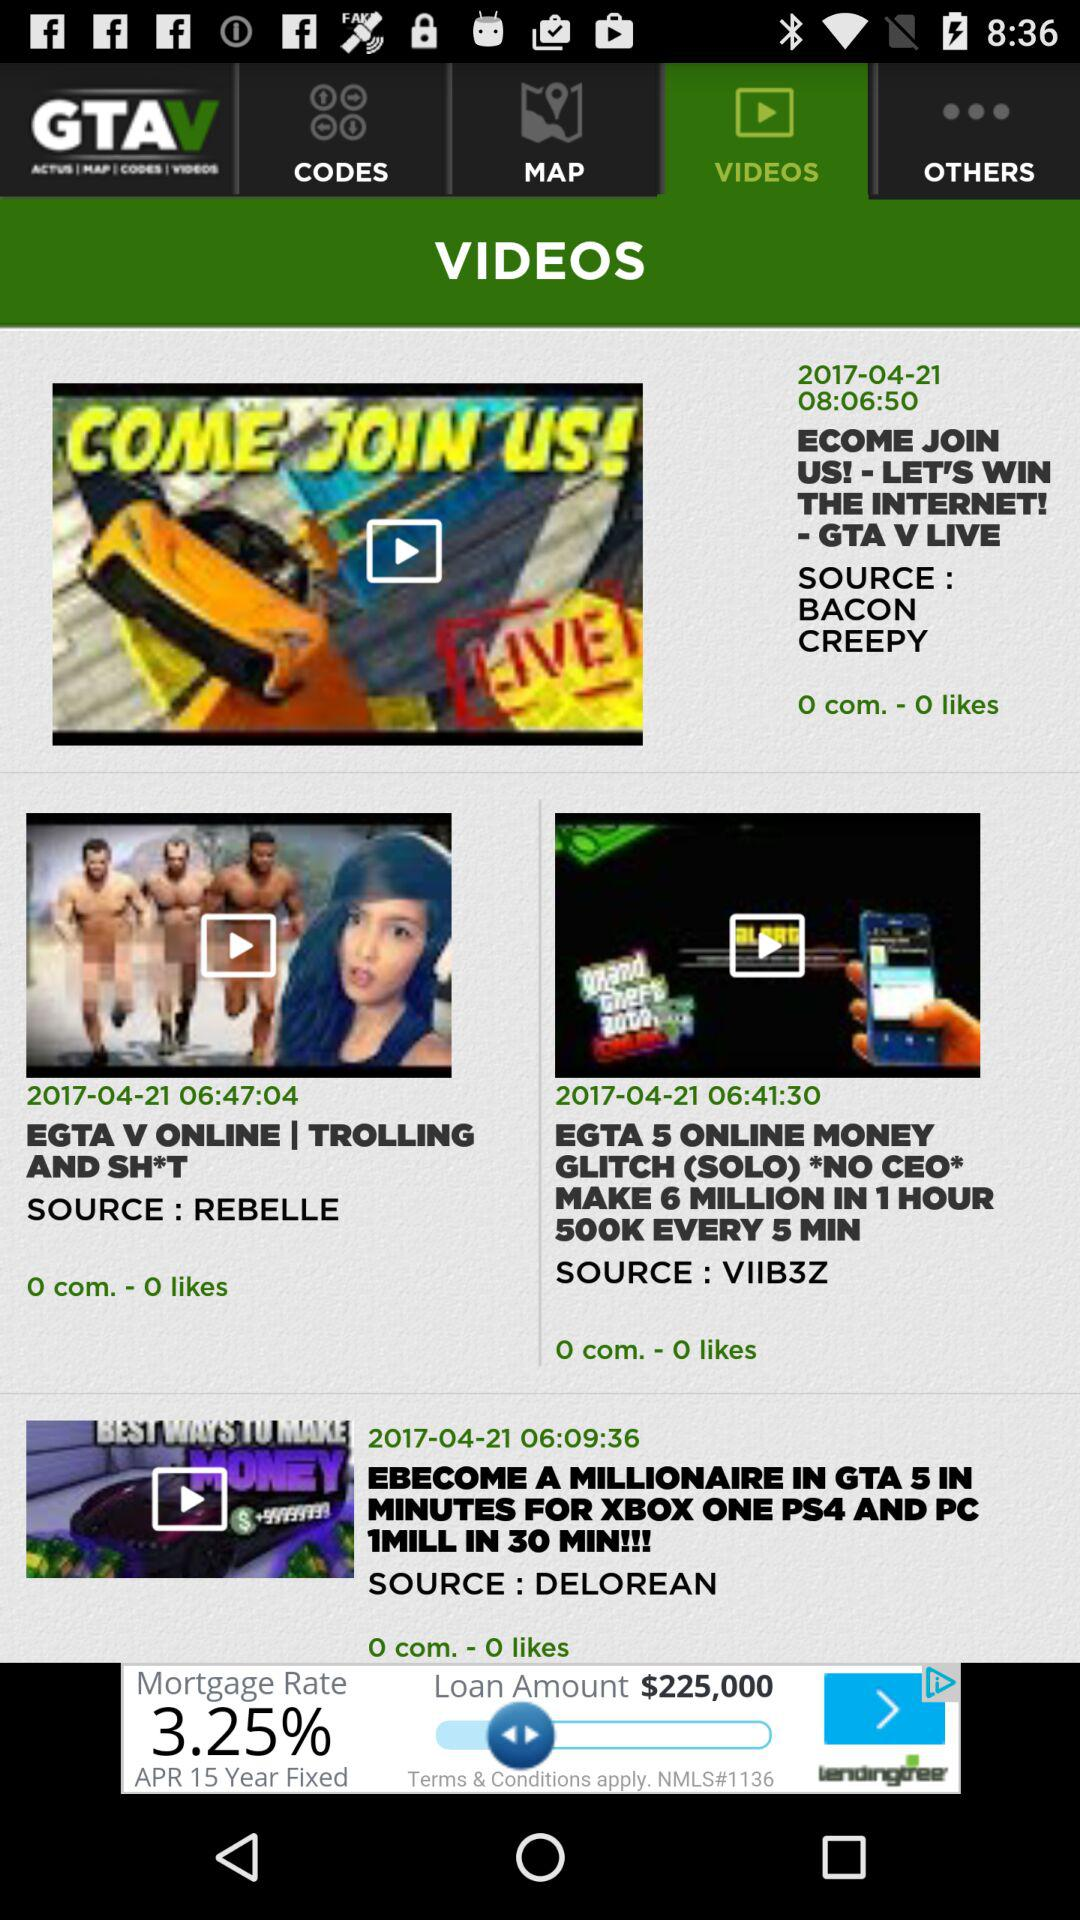What is the source of "EGTA V ONLINE | TROLLING AND SH*T"? The source is "REBELLE". 